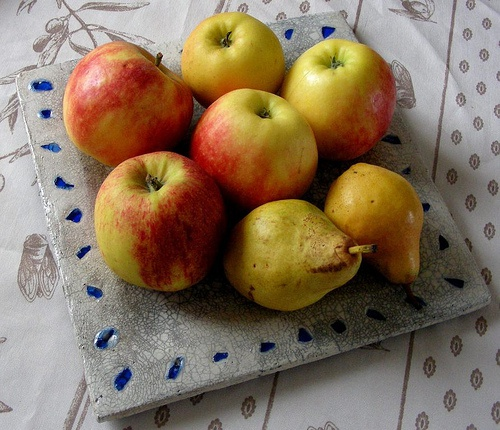Describe the objects in this image and their specific colors. I can see a apple in gray, maroon, olive, and black tones in this image. 